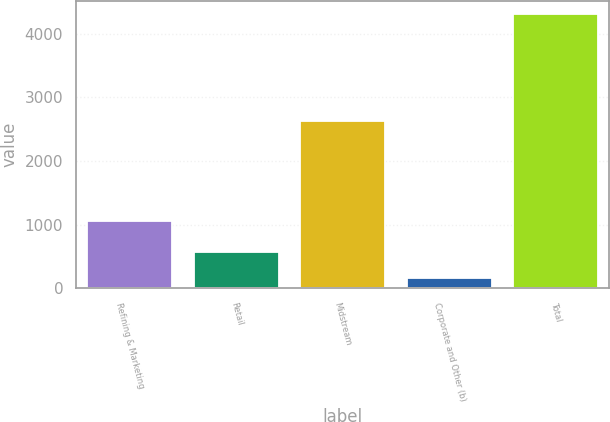<chart> <loc_0><loc_0><loc_500><loc_500><bar_chart><fcel>Refining & Marketing<fcel>Retail<fcel>Midstream<fcel>Corporate and Other (b)<fcel>Total<nl><fcel>1057<fcel>571.7<fcel>2630<fcel>157<fcel>4304<nl></chart> 